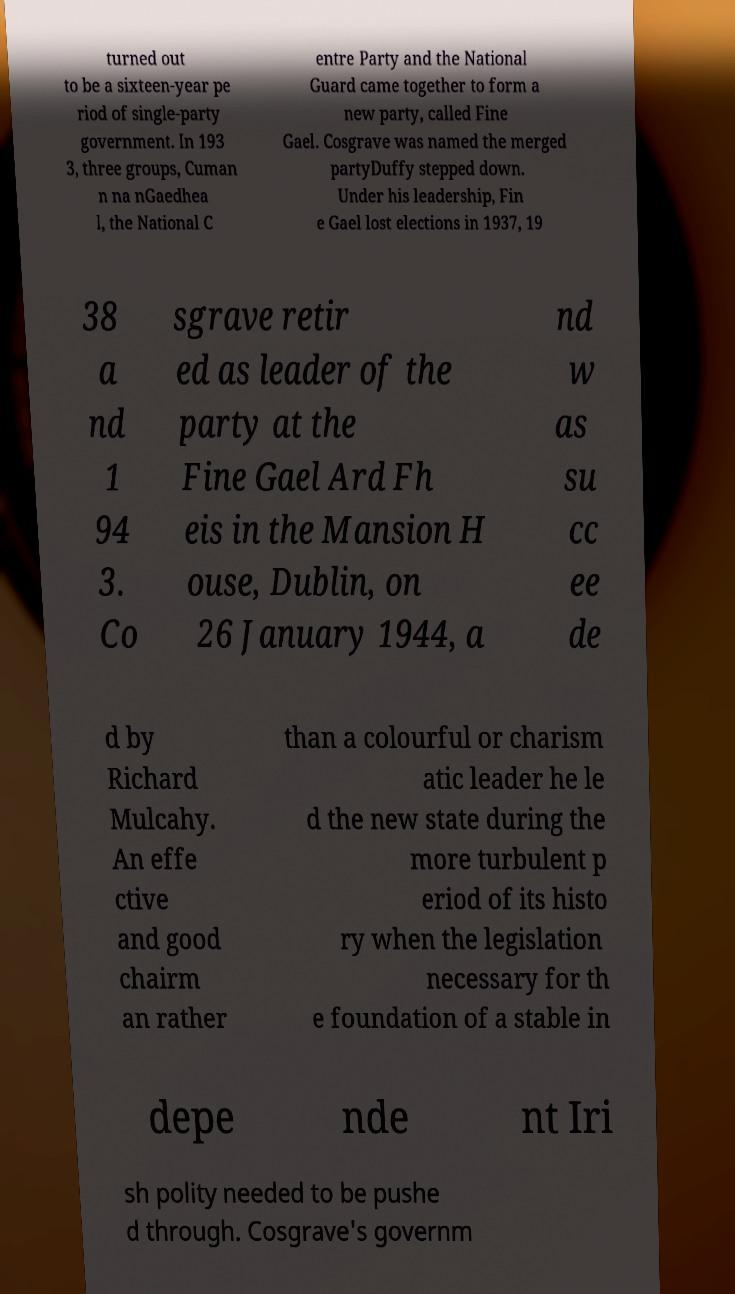Can you accurately transcribe the text from the provided image for me? turned out to be a sixteen-year pe riod of single-party government. In 193 3, three groups, Cuman n na nGaedhea l, the National C entre Party and the National Guard came together to form a new party, called Fine Gael. Cosgrave was named the merged partyDuffy stepped down. Under his leadership, Fin e Gael lost elections in 1937, 19 38 a nd 1 94 3. Co sgrave retir ed as leader of the party at the Fine Gael Ard Fh eis in the Mansion H ouse, Dublin, on 26 January 1944, a nd w as su cc ee de d by Richard Mulcahy. An effe ctive and good chairm an rather than a colourful or charism atic leader he le d the new state during the more turbulent p eriod of its histo ry when the legislation necessary for th e foundation of a stable in depe nde nt Iri sh polity needed to be pushe d through. Cosgrave's governm 